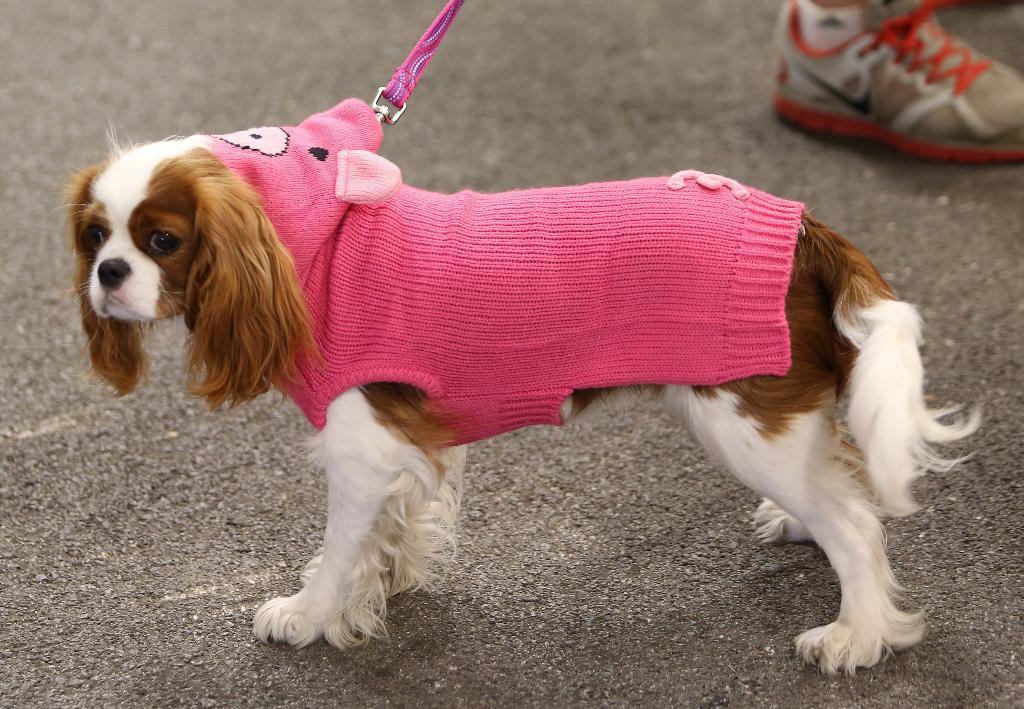Can you describe this image briefly? In this image we can see the dog with the pink color clothes and also the belt. In the background we can see some persons' shoe. We can also see the road. 